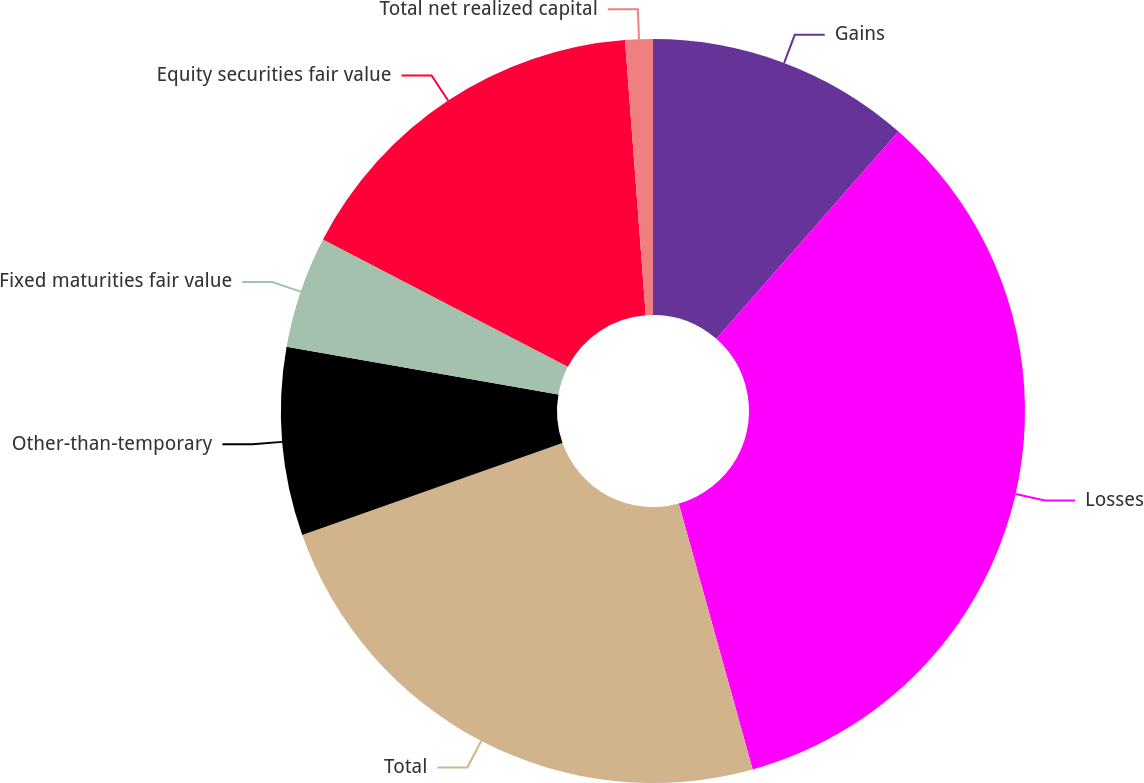Convert chart to OTSL. <chart><loc_0><loc_0><loc_500><loc_500><pie_chart><fcel>Gains<fcel>Losses<fcel>Total<fcel>Other-than-temporary<fcel>Fixed maturities fair value<fcel>Equity securities fair value<fcel>Total net realized capital<nl><fcel>11.47%<fcel>34.22%<fcel>23.91%<fcel>8.17%<fcel>4.87%<fcel>16.17%<fcel>1.2%<nl></chart> 